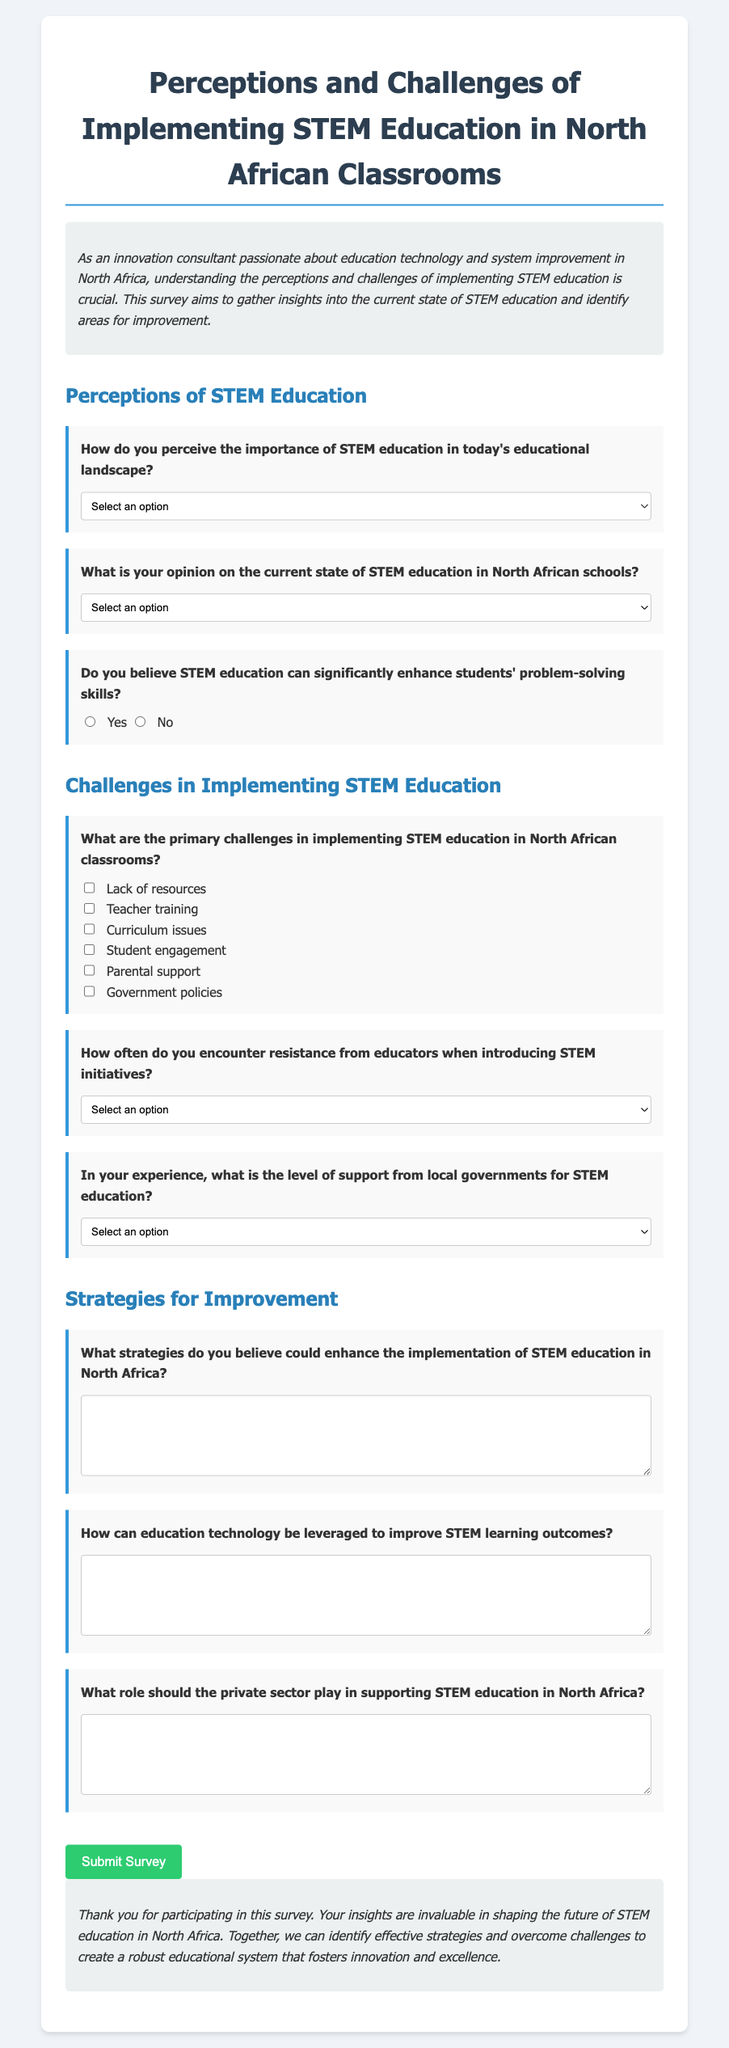What is the title of the survey? The title of the survey is displayed prominently at the top of the document.
Answer: Perceptions and Challenges of Implementing STEM Education in North African Classrooms How many primary challenges are listed for implementing STEM education? There are six primary challenges listed as checkboxes in the document.
Answer: 6 What option reflects the perceived importance of STEM education? The survey provides five options regarding the importance of STEM education, including one labeled "very important."
Answer: Very important What level of government support is mentioned as an option in the survey? The survey includes four levels of government support that respondents can select from.
Answer: High What type of question is asked regarding strategies for improvement in STEM education? The survey includes an open-ended question asking for respondents' opinions on strategies that could enhance STEM education.
Answer: Strategies to enhance STEM education How is the survey's introduction characterized? The introduction of the survey is designed to provide context for the questions that follow, emphasizing its significance.
Answer: As an innovation consultant passionate about education technology and system improvement in North Africa What area does the question regarding technology focus on? The question specifically addresses the role of education technology in improving STEM learning outcomes.
Answer: Education technology How often are respondents asked about resistance from educators? Respondents have a multiple-choice question selecting how often they encounter educator resistance to STEM initiatives.
Answer: Resistance from educators 